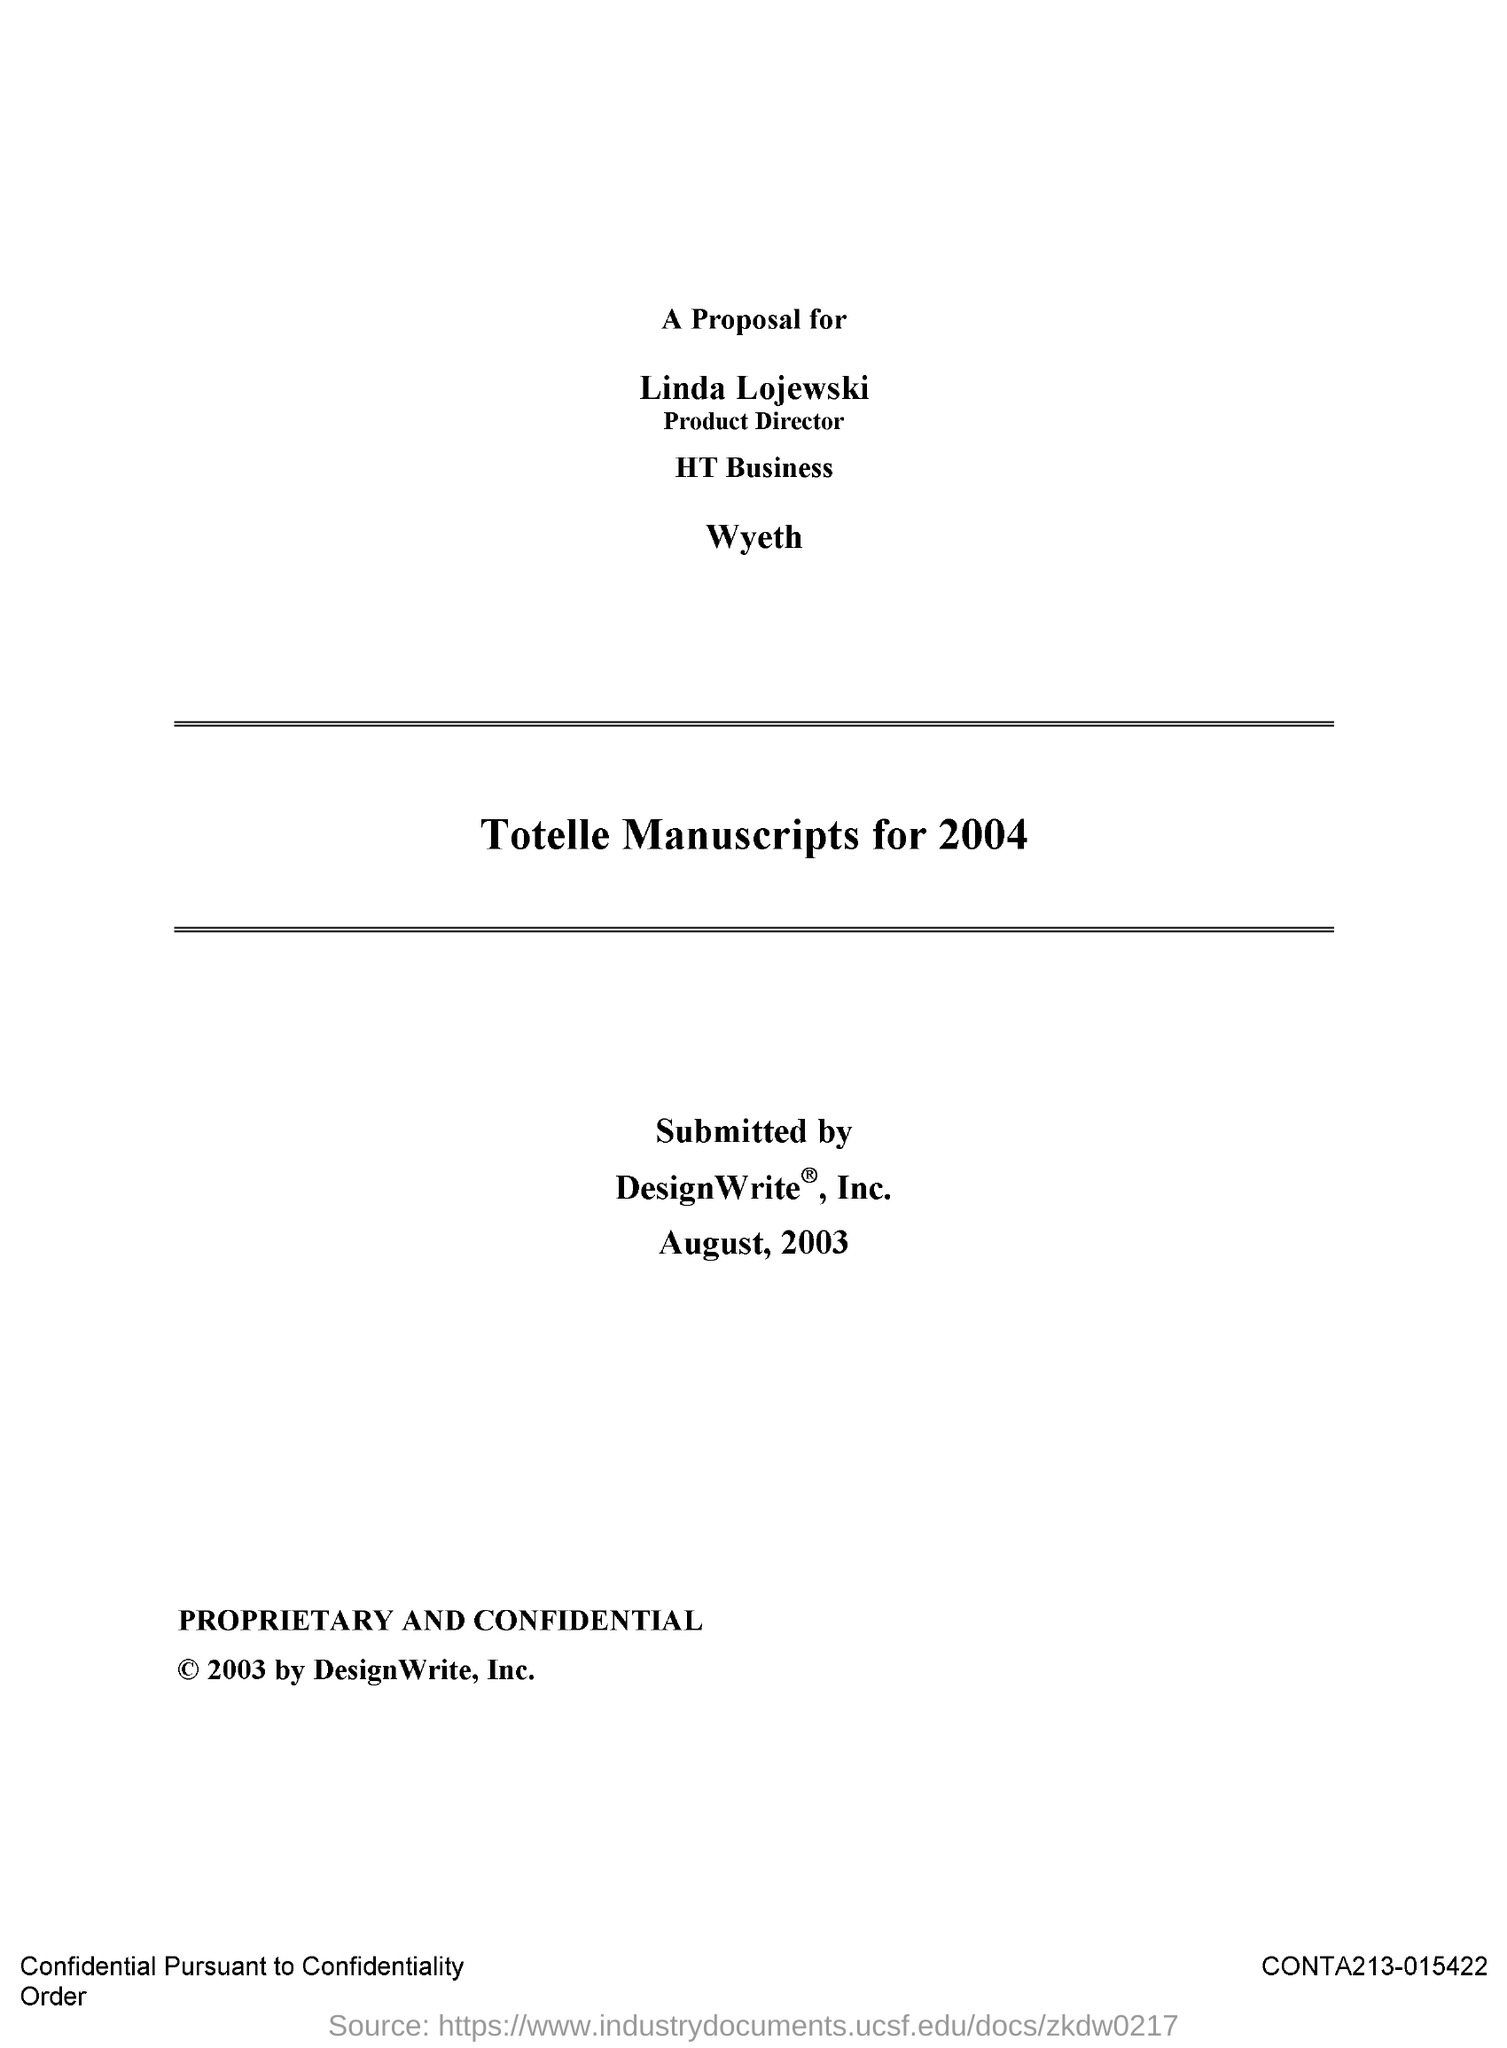Specify some key components in this picture. Linda Lojewski is the Product Director. 